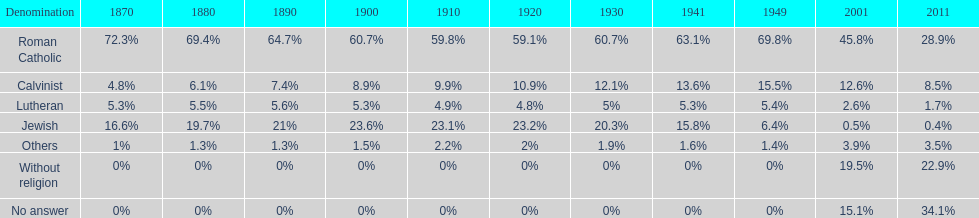Which denomination has the highest margin? Roman Catholic. 